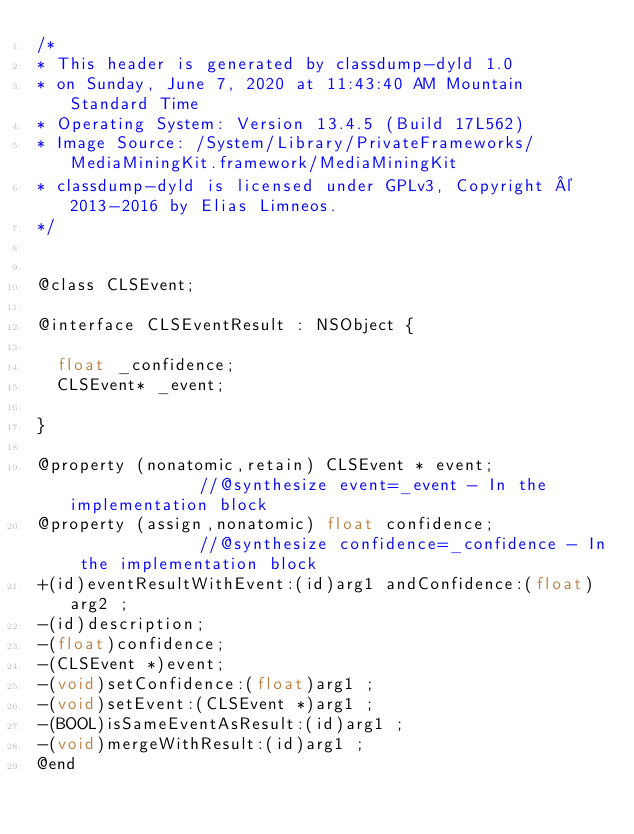<code> <loc_0><loc_0><loc_500><loc_500><_C_>/*
* This header is generated by classdump-dyld 1.0
* on Sunday, June 7, 2020 at 11:43:40 AM Mountain Standard Time
* Operating System: Version 13.4.5 (Build 17L562)
* Image Source: /System/Library/PrivateFrameworks/MediaMiningKit.framework/MediaMiningKit
* classdump-dyld is licensed under GPLv3, Copyright © 2013-2016 by Elias Limneos.
*/


@class CLSEvent;

@interface CLSEventResult : NSObject {

	float _confidence;
	CLSEvent* _event;

}

@property (nonatomic,retain) CLSEvent * event;              //@synthesize event=_event - In the implementation block
@property (assign,nonatomic) float confidence;              //@synthesize confidence=_confidence - In the implementation block
+(id)eventResultWithEvent:(id)arg1 andConfidence:(float)arg2 ;
-(id)description;
-(float)confidence;
-(CLSEvent *)event;
-(void)setConfidence:(float)arg1 ;
-(void)setEvent:(CLSEvent *)arg1 ;
-(BOOL)isSameEventAsResult:(id)arg1 ;
-(void)mergeWithResult:(id)arg1 ;
@end

</code> 